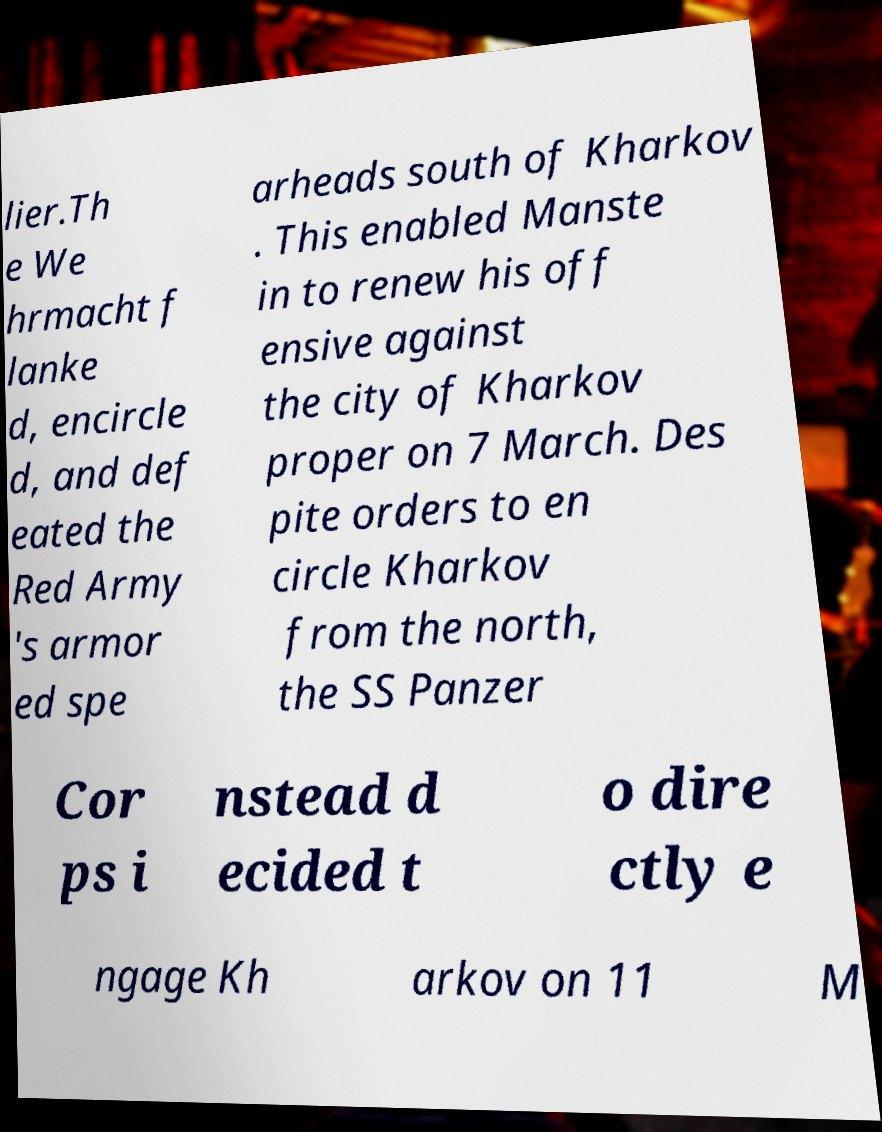For documentation purposes, I need the text within this image transcribed. Could you provide that? lier.Th e We hrmacht f lanke d, encircle d, and def eated the Red Army 's armor ed spe arheads south of Kharkov . This enabled Manste in to renew his off ensive against the city of Kharkov proper on 7 March. Des pite orders to en circle Kharkov from the north, the SS Panzer Cor ps i nstead d ecided t o dire ctly e ngage Kh arkov on 11 M 